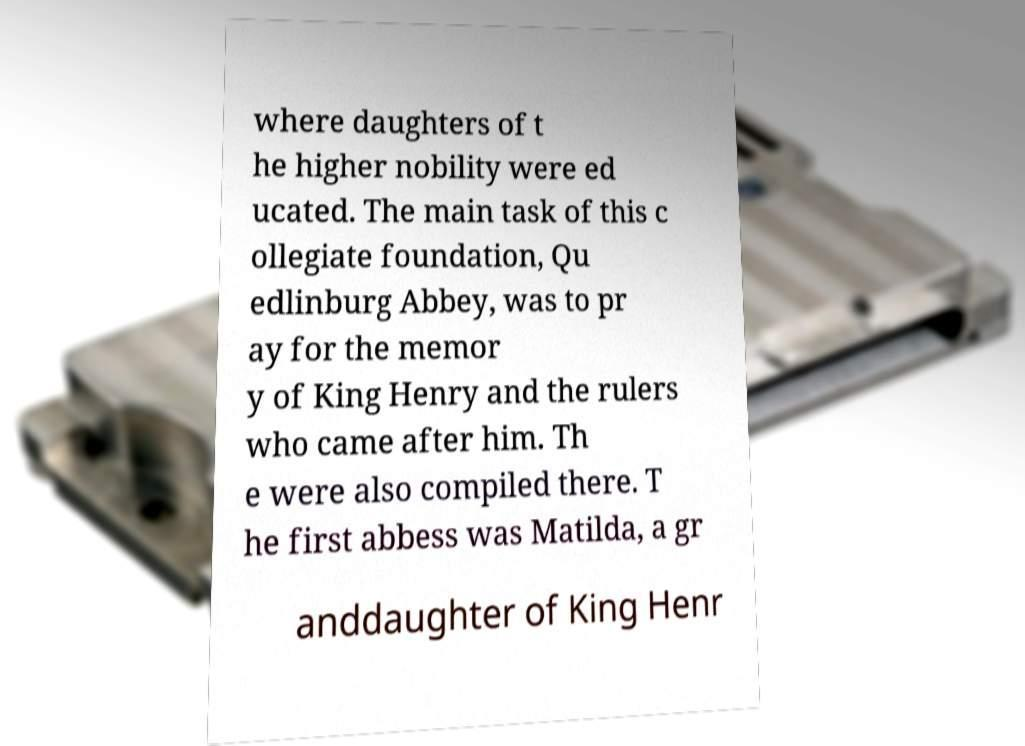Could you assist in decoding the text presented in this image and type it out clearly? where daughters of t he higher nobility were ed ucated. The main task of this c ollegiate foundation, Qu edlinburg Abbey, was to pr ay for the memor y of King Henry and the rulers who came after him. Th e were also compiled there. T he first abbess was Matilda, a gr anddaughter of King Henr 